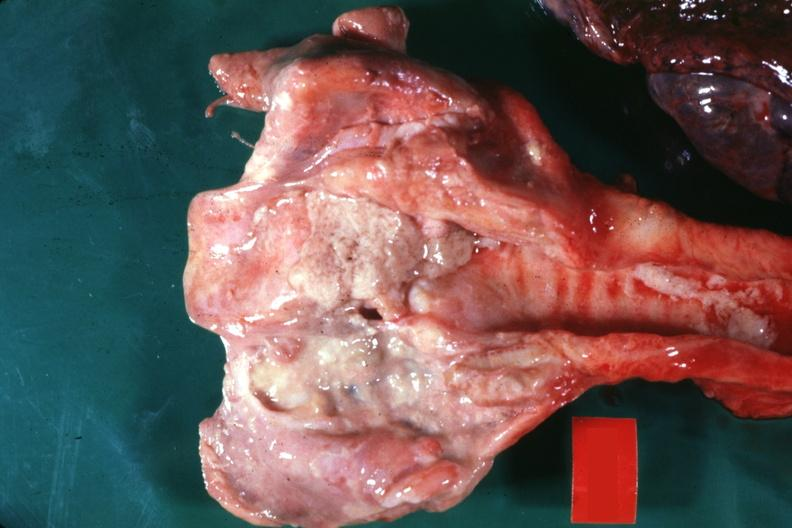where is this?
Answer the question using a single word or phrase. Oral 